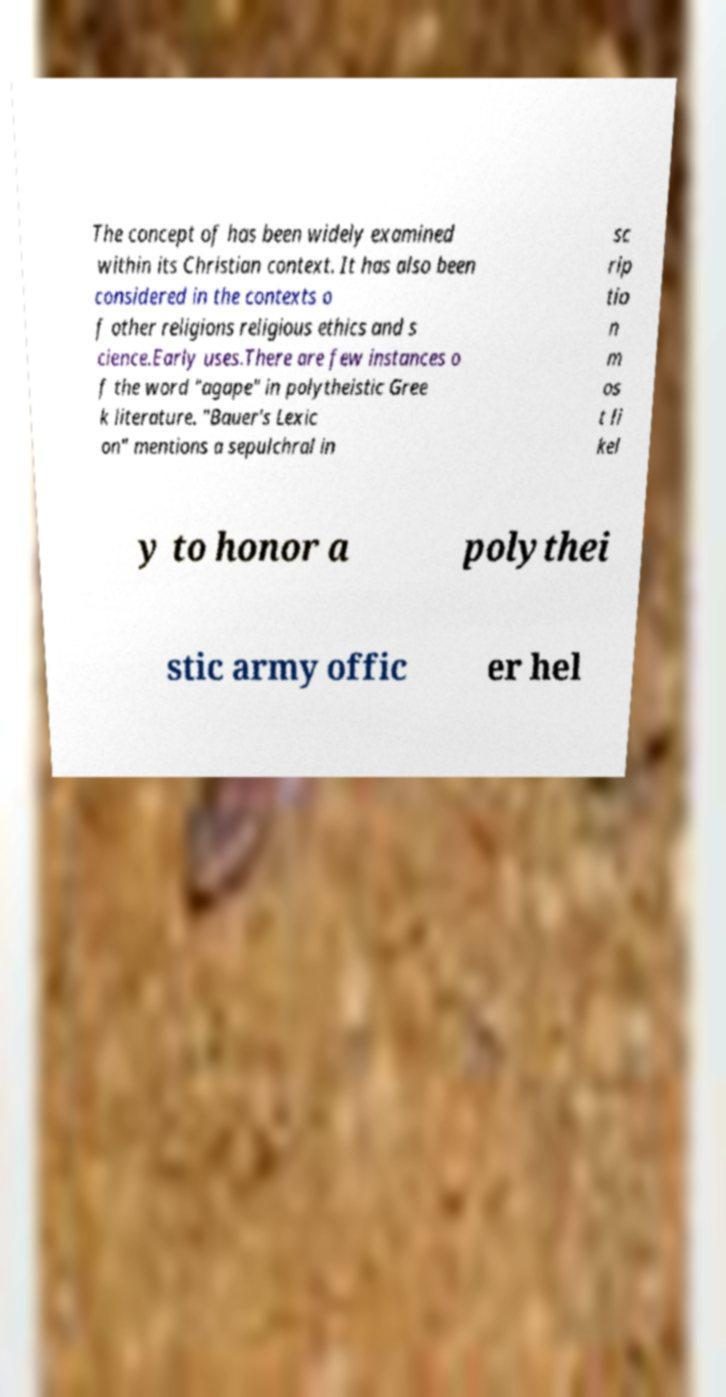Could you assist in decoding the text presented in this image and type it out clearly? The concept of has been widely examined within its Christian context. It has also been considered in the contexts o f other religions religious ethics and s cience.Early uses.There are few instances o f the word "agape" in polytheistic Gree k literature. "Bauer's Lexic on" mentions a sepulchral in sc rip tio n m os t li kel y to honor a polythei stic army offic er hel 